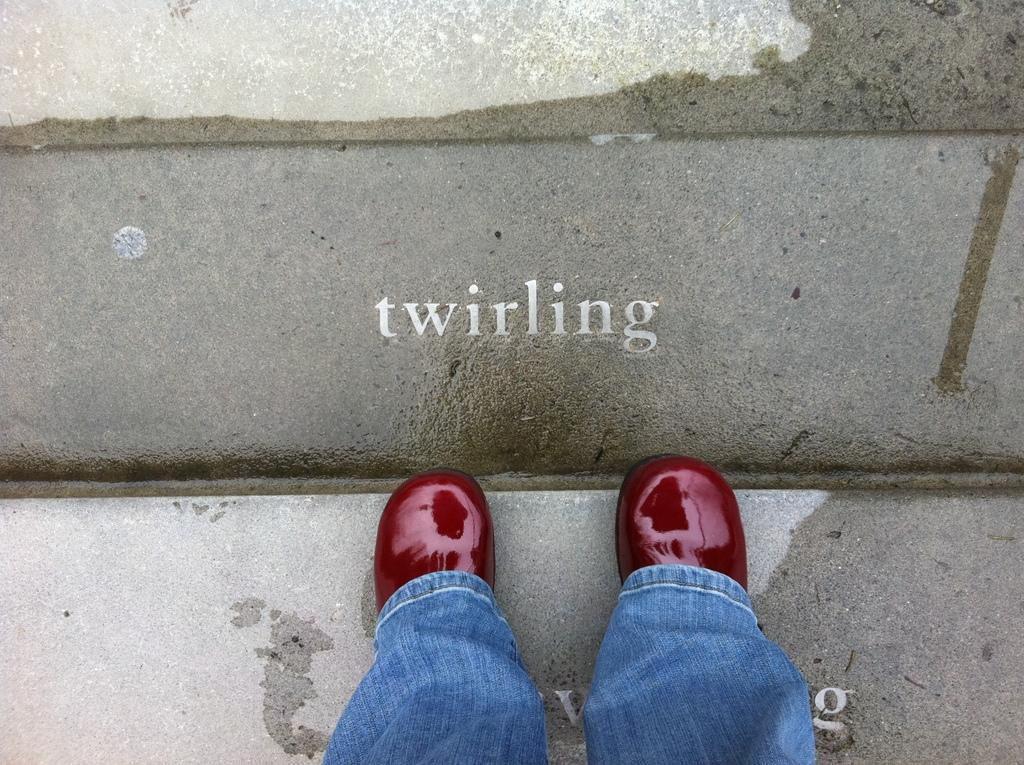What is visible at the bottom side of the image? There are two legs visible in the image. Where are the legs located in relation to the rest of the image? The legs are at the bottom side of the image. What surface are the legs standing on? The legs are on a stair. What color is the crayon being used to draw on the legs in the image? There is no crayon or drawing present in the image. How does the pump affect the movement of the legs in the image? There is no pump present in the image, so it cannot affect the movement of the legs. 